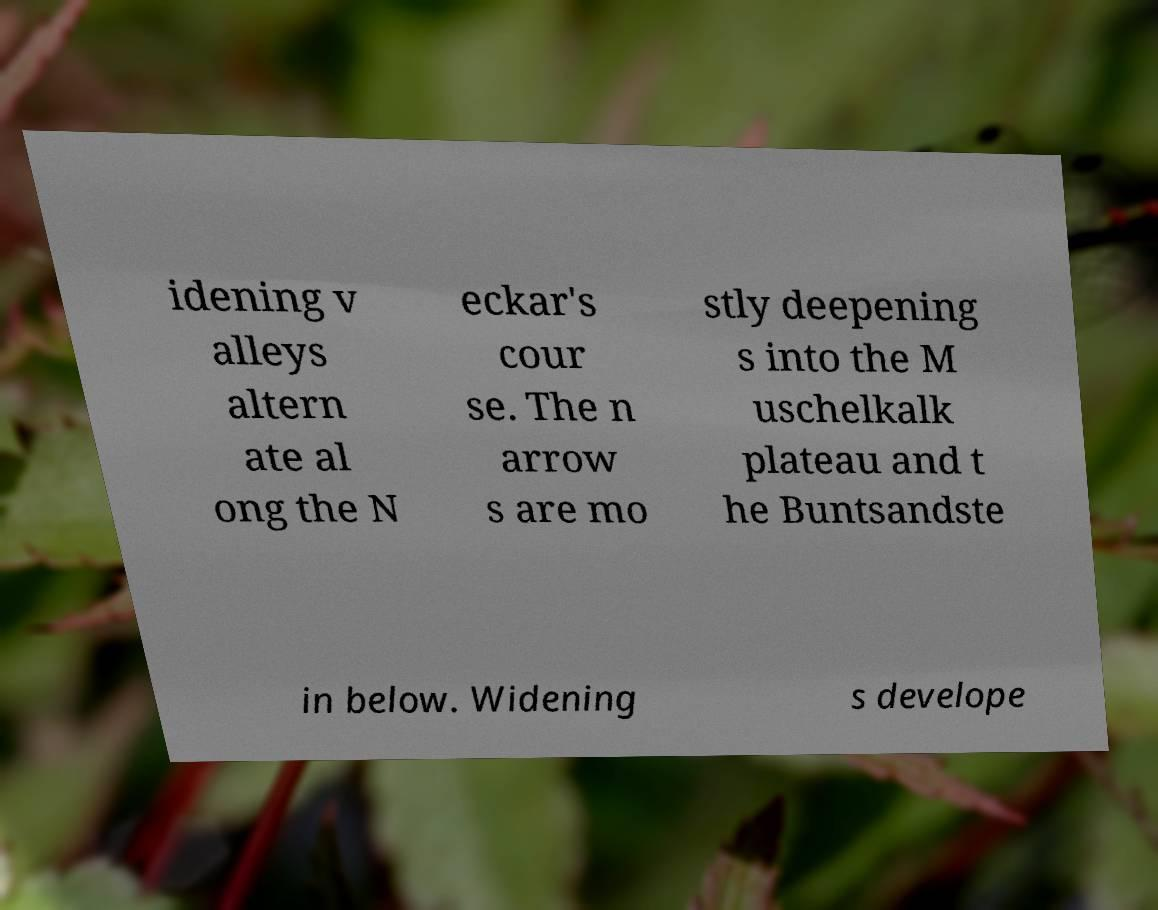Can you accurately transcribe the text from the provided image for me? idening v alleys altern ate al ong the N eckar's cour se. The n arrow s are mo stly deepening s into the M uschelkalk plateau and t he Buntsandste in below. Widening s develope 